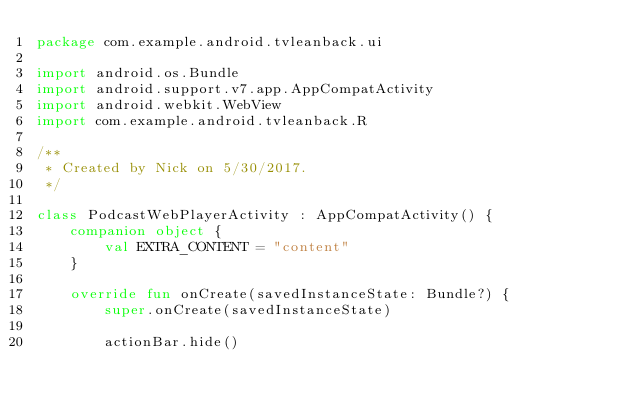Convert code to text. <code><loc_0><loc_0><loc_500><loc_500><_Kotlin_>package com.example.android.tvleanback.ui

import android.os.Bundle
import android.support.v7.app.AppCompatActivity
import android.webkit.WebView
import com.example.android.tvleanback.R

/**
 * Created by Nick on 5/30/2017.
 */

class PodcastWebPlayerActivity : AppCompatActivity() {
    companion object {
        val EXTRA_CONTENT = "content"
    }

    override fun onCreate(savedInstanceState: Bundle?) {
        super.onCreate(savedInstanceState)

        actionBar.hide()</code> 